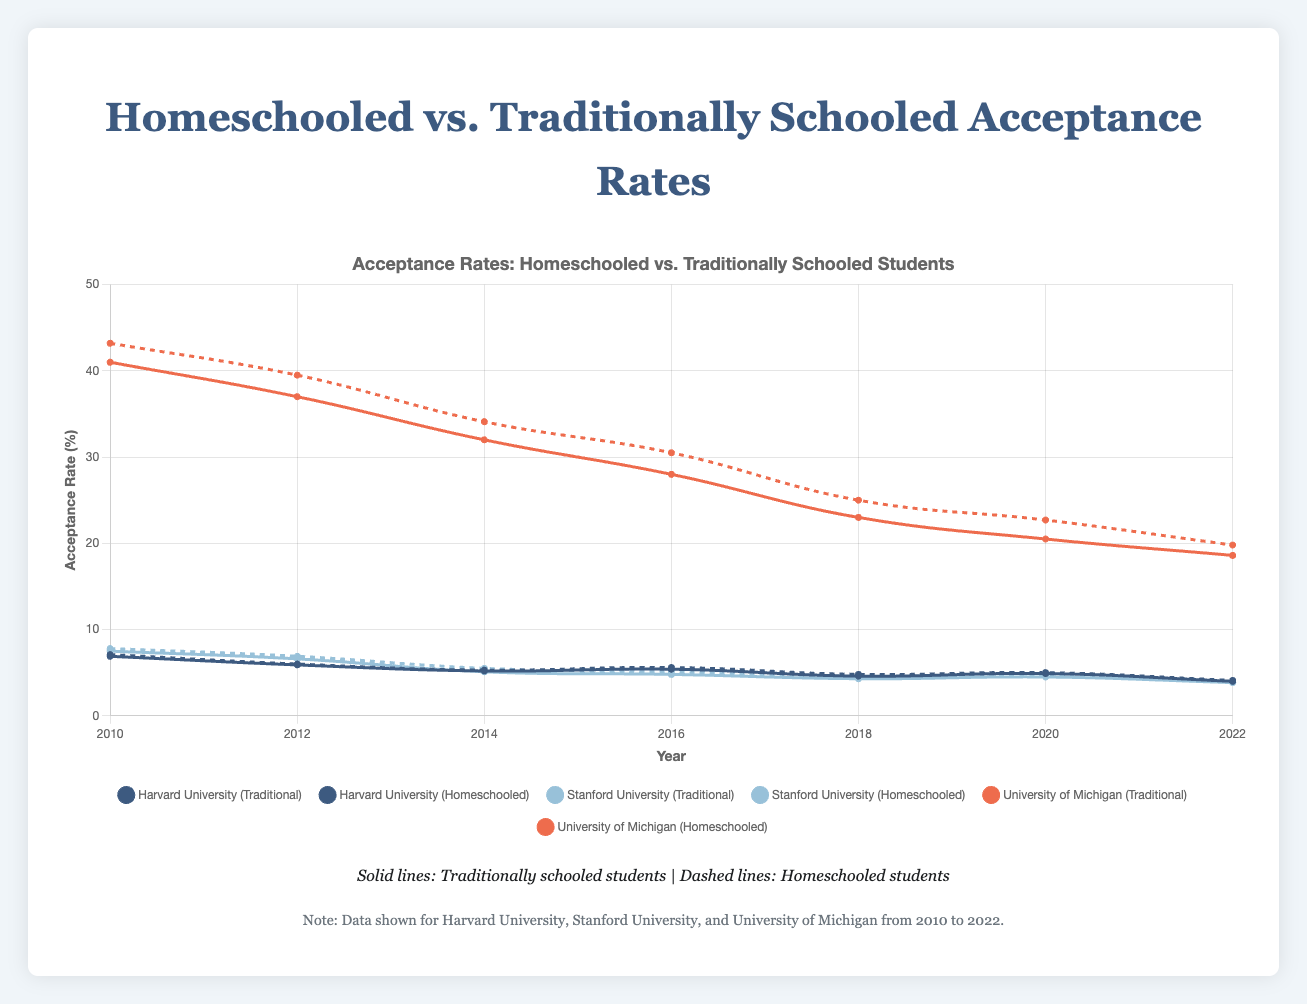What is the average acceptance rate for homeschooled students at Harvard University over the period shown? To find the average acceptance rate, sum the acceptance rates for each year and then divide by the number of years. The rates are 7.1, 6.0, 5.3, 5.6, 4.8, 5.0, and 4.1. The total is 37.9. Dividing by 7 years gives an average of approximately 5.41%.
Answer: 5.41% Which year showed the smallest difference between the acceptance rates of homeschooled and traditionally schooled students at Stanford University? First, calculate the differences for each year: 2010: 7.8 - 7.5 = 0.3, 2012: 6.9 - 6.6 = 0.3, 2014: 5.5 - 5.1 = 0.4, 2016: 5.1 - 4.8 = 0.3, 2018: 4.5 - 4.3 = 0.2, 2020: 4.7 - 4.5 = 0.2, 2022: 4.0 - 3.85 = 0.15. The smallest difference was in 2022 with a difference of 0.15.
Answer: 2022 How did the acceptance rate for homeschooled students at the University of Michigan trend over the decade? The acceptance rate for homeschooled students at the University of Michigan is as follows: 43.2 (2010), 39.5 (2012), 34.1 (2014), 30.5 (2016), 25.0 (2018), 22.7 (2020), and 19.8 (2022). The trend shows a continuous decline over the decade.
Answer: Declining Which university had the highest acceptance rate for traditionally schooled students in 2014? In 2014, the acceptance rates for traditionally schooled students are: Harvard University 5.2%, Stanford University 5.1%, and University of Michigan 32.0%. The University of Michigan had the highest acceptance rate.
Answer: University of Michigan By how much did the acceptance rates for homeschooled students at Harvard University decrease from 2010 to 2022? The acceptance rate for homeschooled students at Harvard University was 7.1% in 2010 and 4.1% in 2022. The decrease is 7.1 - 4.1 = 3.0%.
Answer: 3.0% Is there a year where homeschooled students had a lower acceptance rate than traditionally schooled students at any of the three universities? Looking at the data, homeschooled students always have an equal or higher acceptance rate than traditionally schooled students in all years and universities. Therefore, there is no year where homeschooled students had a lower acceptance rate.
Answer: No What was the overall trend for acceptance rates for traditionally schooled students at Stanford University from 2010 to 2022? The acceptance rates trend for traditionally schooled students at Stanford: 7.5% (2010), 6.6% (2012), 5.1% (2014), 4.8% (2016), 4.3% (2018), 4.5% (2020), and 3.85% (2022). This shows an overall declining trend.
Answer: Declining For traditionally schooled students, which university showed the most significant decrease in acceptance rates from 2010 to 2022? The acceptance rates for traditionally schooled students from 2010 to 2022 are: Harvard University 6.9% to 4.0% (a decrease of 2.9%), Stanford University 7.5% to 3.85% (a decrease of 3.65%), and University of Michigan 41.0% to 18.6% (a decrease of 22.4%). The University of Michigan showed the most significant decrease.
Answer: University of Michigan 